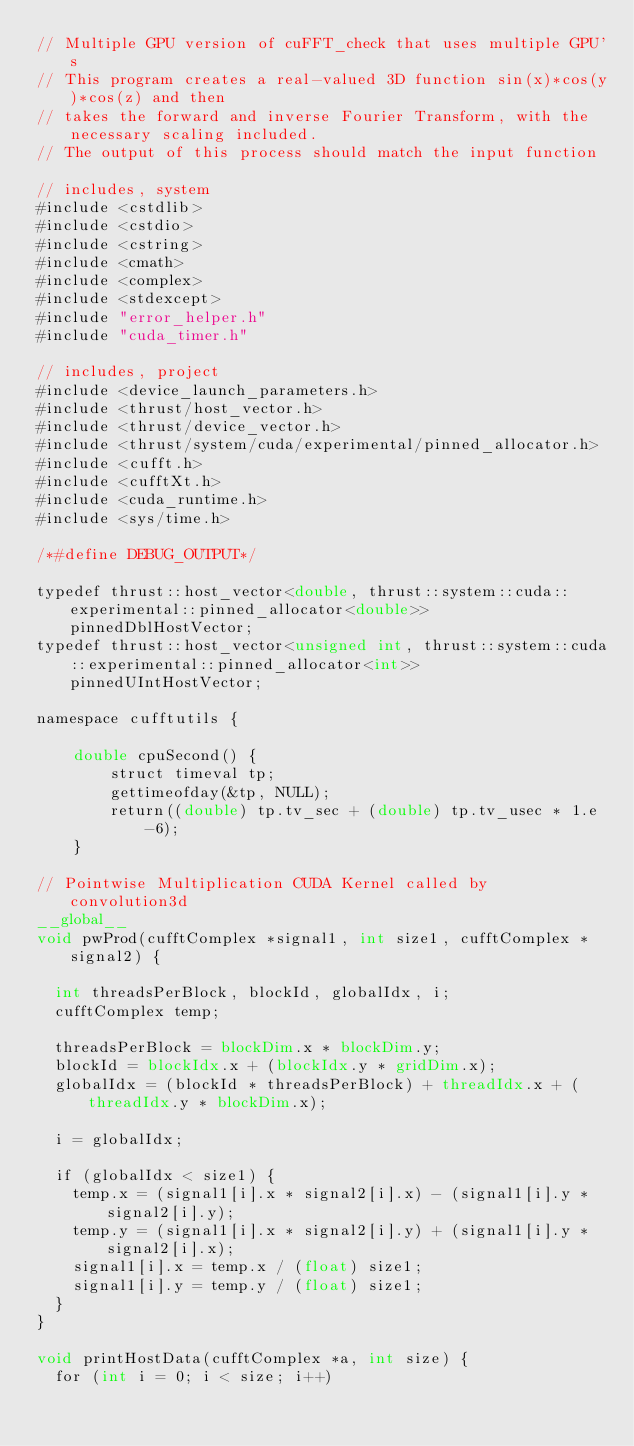<code> <loc_0><loc_0><loc_500><loc_500><_Cuda_>// Multiple GPU version of cuFFT_check that uses multiple GPU's
// This program creates a real-valued 3D function sin(x)*cos(y)*cos(z) and then 
// takes the forward and inverse Fourier Transform, with the necessary scaling included. 
// The output of this process should match the input function

// includes, system
#include <cstdlib>
#include <cstdio>
#include <cstring>
#include <cmath>
#include <complex>
#include <stdexcept>
#include "error_helper.h"
#include "cuda_timer.h"

// includes, project
#include <device_launch_parameters.h>
#include <thrust/host_vector.h>
#include <thrust/device_vector.h>
#include <thrust/system/cuda/experimental/pinned_allocator.h>
#include <cufft.h>
#include <cufftXt.h>
#include <cuda_runtime.h>
#include <sys/time.h>

/*#define DEBUG_OUTPUT*/

typedef thrust::host_vector<double, thrust::system::cuda::experimental::pinned_allocator<double>> pinnedDblHostVector;
typedef thrust::host_vector<unsigned int, thrust::system::cuda::experimental::pinned_allocator<int>> pinnedUIntHostVector;

namespace cufftutils {
    
    double cpuSecond() {
        struct timeval tp;
        gettimeofday(&tp, NULL);
        return((double) tp.tv_sec + (double) tp.tv_usec * 1.e-6);
    }

// Pointwise Multiplication CUDA Kernel called by convolution3d
__global__ 
void pwProd(cufftComplex *signal1, int size1, cufftComplex *signal2) {

  int threadsPerBlock, blockId, globalIdx, i;
  cufftComplex temp;

  threadsPerBlock = blockDim.x * blockDim.y;
  blockId = blockIdx.x + (blockIdx.y * gridDim.x);
  globalIdx = (blockId * threadsPerBlock) + threadIdx.x + (threadIdx.y * blockDim.x);

  i = globalIdx;

  if (globalIdx < size1) {
    temp.x = (signal1[i].x * signal2[i].x) - (signal1[i].y * signal2[i].y);
    temp.y = (signal1[i].x * signal2[i].y) + (signal1[i].y * signal2[i].x);
    signal1[i].x = temp.x / (float) size1;
    signal1[i].y = temp.y / (float) size1;
  }
}

void printHostData(cufftComplex *a, int size) {
  for (int i = 0; i < size; i++)</code> 